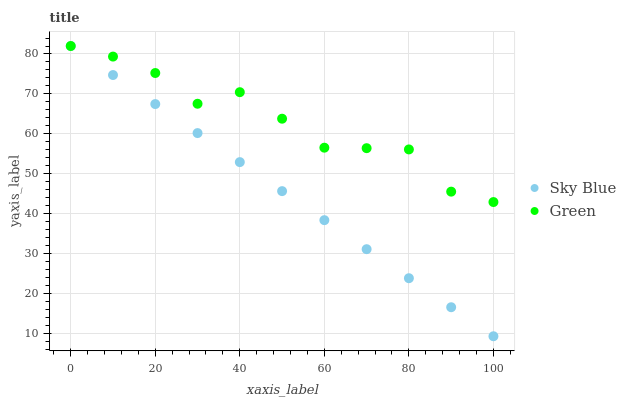Does Sky Blue have the minimum area under the curve?
Answer yes or no. Yes. Does Green have the maximum area under the curve?
Answer yes or no. Yes. Does Green have the minimum area under the curve?
Answer yes or no. No. Is Sky Blue the smoothest?
Answer yes or no. Yes. Is Green the roughest?
Answer yes or no. Yes. Is Green the smoothest?
Answer yes or no. No. Does Sky Blue have the lowest value?
Answer yes or no. Yes. Does Green have the lowest value?
Answer yes or no. No. Does Green have the highest value?
Answer yes or no. Yes. Does Sky Blue intersect Green?
Answer yes or no. Yes. Is Sky Blue less than Green?
Answer yes or no. No. Is Sky Blue greater than Green?
Answer yes or no. No. 